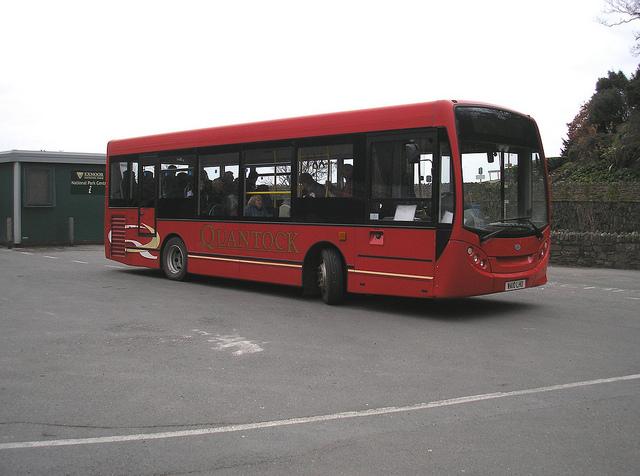What is the name of the bus company?
Concise answer only. Quantock. Is the bus in a parking lot?
Quick response, please. Yes. What word is written across the bus?
Quick response, please. Quantock. Is anyone driving the bus?
Give a very brief answer. No. What is the white symbol on the red bus?
Give a very brief answer. Q. Is this a double decker bus?
Concise answer only. No. 